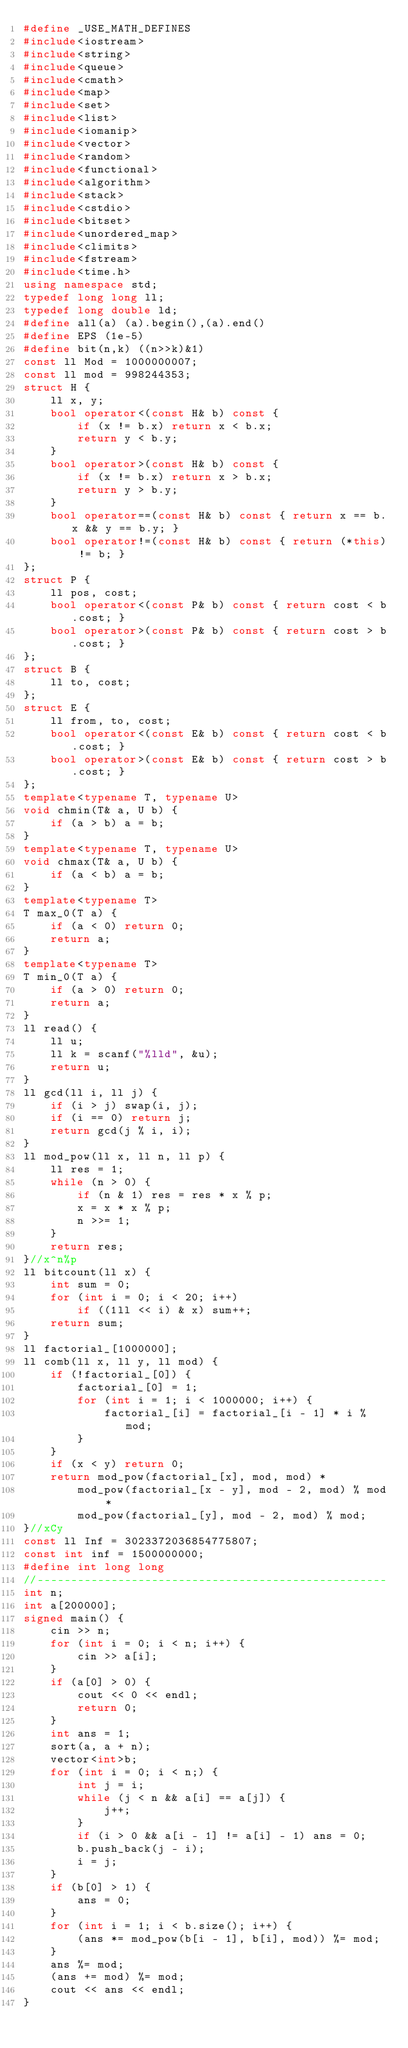<code> <loc_0><loc_0><loc_500><loc_500><_C++_>#define _USE_MATH_DEFINES
#include<iostream>
#include<string>
#include<queue>
#include<cmath>
#include<map>
#include<set>
#include<list>
#include<iomanip>
#include<vector>
#include<random>
#include<functional>
#include<algorithm>
#include<stack>
#include<cstdio>
#include<bitset>
#include<unordered_map>
#include<climits>
#include<fstream>
#include<time.h>
using namespace std;
typedef long long ll;
typedef long double ld;
#define all(a) (a).begin(),(a).end()
#define EPS (1e-5)
#define bit(n,k) ((n>>k)&1)
const ll Mod = 1000000007;
const ll mod = 998244353;
struct H {
	ll x, y;
	bool operator<(const H& b) const {
		if (x != b.x) return x < b.x;
		return y < b.y;
	}
	bool operator>(const H& b) const {
		if (x != b.x) return x > b.x;
		return y > b.y;
	}
	bool operator==(const H& b) const { return x == b.x && y == b.y; }
	bool operator!=(const H& b) const { return (*this) != b; }
};
struct P {
	ll pos, cost;
	bool operator<(const P& b) const { return cost < b.cost; }
	bool operator>(const P& b) const { return cost > b.cost; }
};
struct B {
	ll to, cost;
};
struct E {
	ll from, to, cost;
	bool operator<(const E& b) const { return cost < b.cost; }
	bool operator>(const E& b) const { return cost > b.cost; }
};
template<typename T, typename U>
void chmin(T& a, U b) {
	if (a > b) a = b;
}
template<typename T, typename U>
void chmax(T& a, U b) {
	if (a < b) a = b;
}
template<typename T>
T max_0(T a) {
	if (a < 0) return 0;
	return a;
}
template<typename T>
T min_0(T a) {
	if (a > 0) return 0;
	return a;
}
ll read() {
	ll u;
	ll k = scanf("%lld", &u);
	return u;
}
ll gcd(ll i, ll j) {
	if (i > j) swap(i, j);
	if (i == 0) return j;
	return gcd(j % i, i);
}
ll mod_pow(ll x, ll n, ll p) {
	ll res = 1;
	while (n > 0) {
		if (n & 1) res = res * x % p;
		x = x * x % p;
		n >>= 1;
	}
	return res;
}//x^n%p
ll bitcount(ll x) {
	int sum = 0;
	for (int i = 0; i < 20; i++) 
		if ((1ll << i) & x) sum++;
	return sum;
}
ll factorial_[1000000];
ll comb(ll x, ll y, ll mod) {
	if (!factorial_[0]) {
		factorial_[0] = 1;
		for (int i = 1; i < 1000000; i++) {
			factorial_[i] = factorial_[i - 1] * i % mod;
		}
	}
	if (x < y) return 0;
	return mod_pow(factorial_[x], mod, mod) *
		mod_pow(factorial_[x - y], mod - 2, mod) % mod *
		mod_pow(factorial_[y], mod - 2, mod) % mod;
}//xCy
const ll Inf = 3023372036854775807;
const int inf = 1500000000;
#define int long long
//----------------------------------------------------
int n;
int a[200000];
signed main() {
	cin >> n;
	for (int i = 0; i < n; i++) {
		cin >> a[i];
	}
	if (a[0] > 0) {
		cout << 0 << endl;
		return 0;
	}
	int ans = 1;
	sort(a, a + n);
	vector<int>b;
	for (int i = 0; i < n;) {
		int j = i;
		while (j < n && a[i] == a[j]) {
			j++;
		}
		if (i > 0 && a[i - 1] != a[i] - 1) ans = 0;
		b.push_back(j - i);
		i = j;
	}
	if (b[0] > 1) {
		ans = 0;
	}
	for (int i = 1; i < b.size(); i++) {
		(ans *= mod_pow(b[i - 1], b[i], mod)) %= mod;
	}
	ans %= mod;
	(ans += mod) %= mod;
	cout << ans << endl;
}</code> 